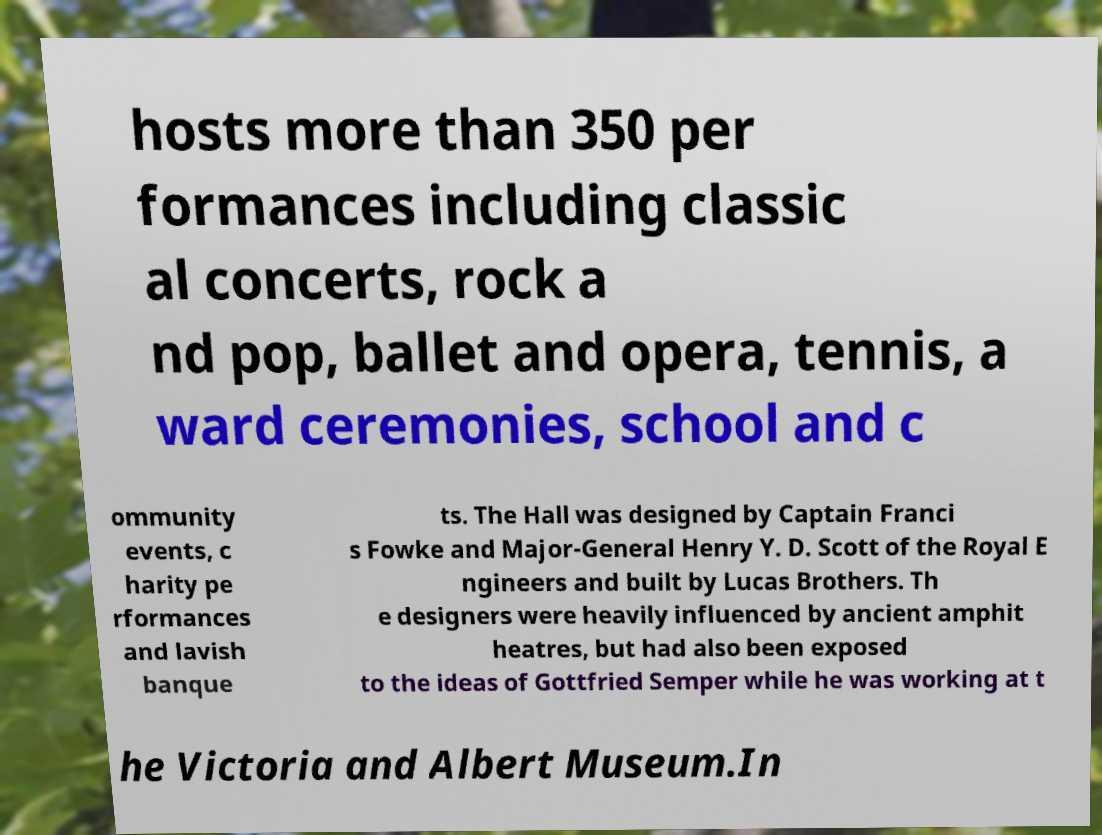Please read and relay the text visible in this image. What does it say? hosts more than 350 per formances including classic al concerts, rock a nd pop, ballet and opera, tennis, a ward ceremonies, school and c ommunity events, c harity pe rformances and lavish banque ts. The Hall was designed by Captain Franci s Fowke and Major-General Henry Y. D. Scott of the Royal E ngineers and built by Lucas Brothers. Th e designers were heavily influenced by ancient amphit heatres, but had also been exposed to the ideas of Gottfried Semper while he was working at t he Victoria and Albert Museum.In 